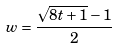Convert formula to latex. <formula><loc_0><loc_0><loc_500><loc_500>w = \frac { \sqrt { 8 t + 1 } - 1 } { 2 }</formula> 